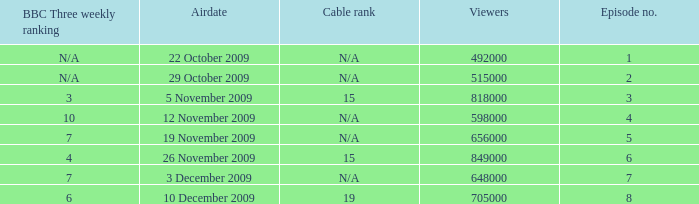What is the cable rank for the airdate of 10 december 2009? 19.0. 